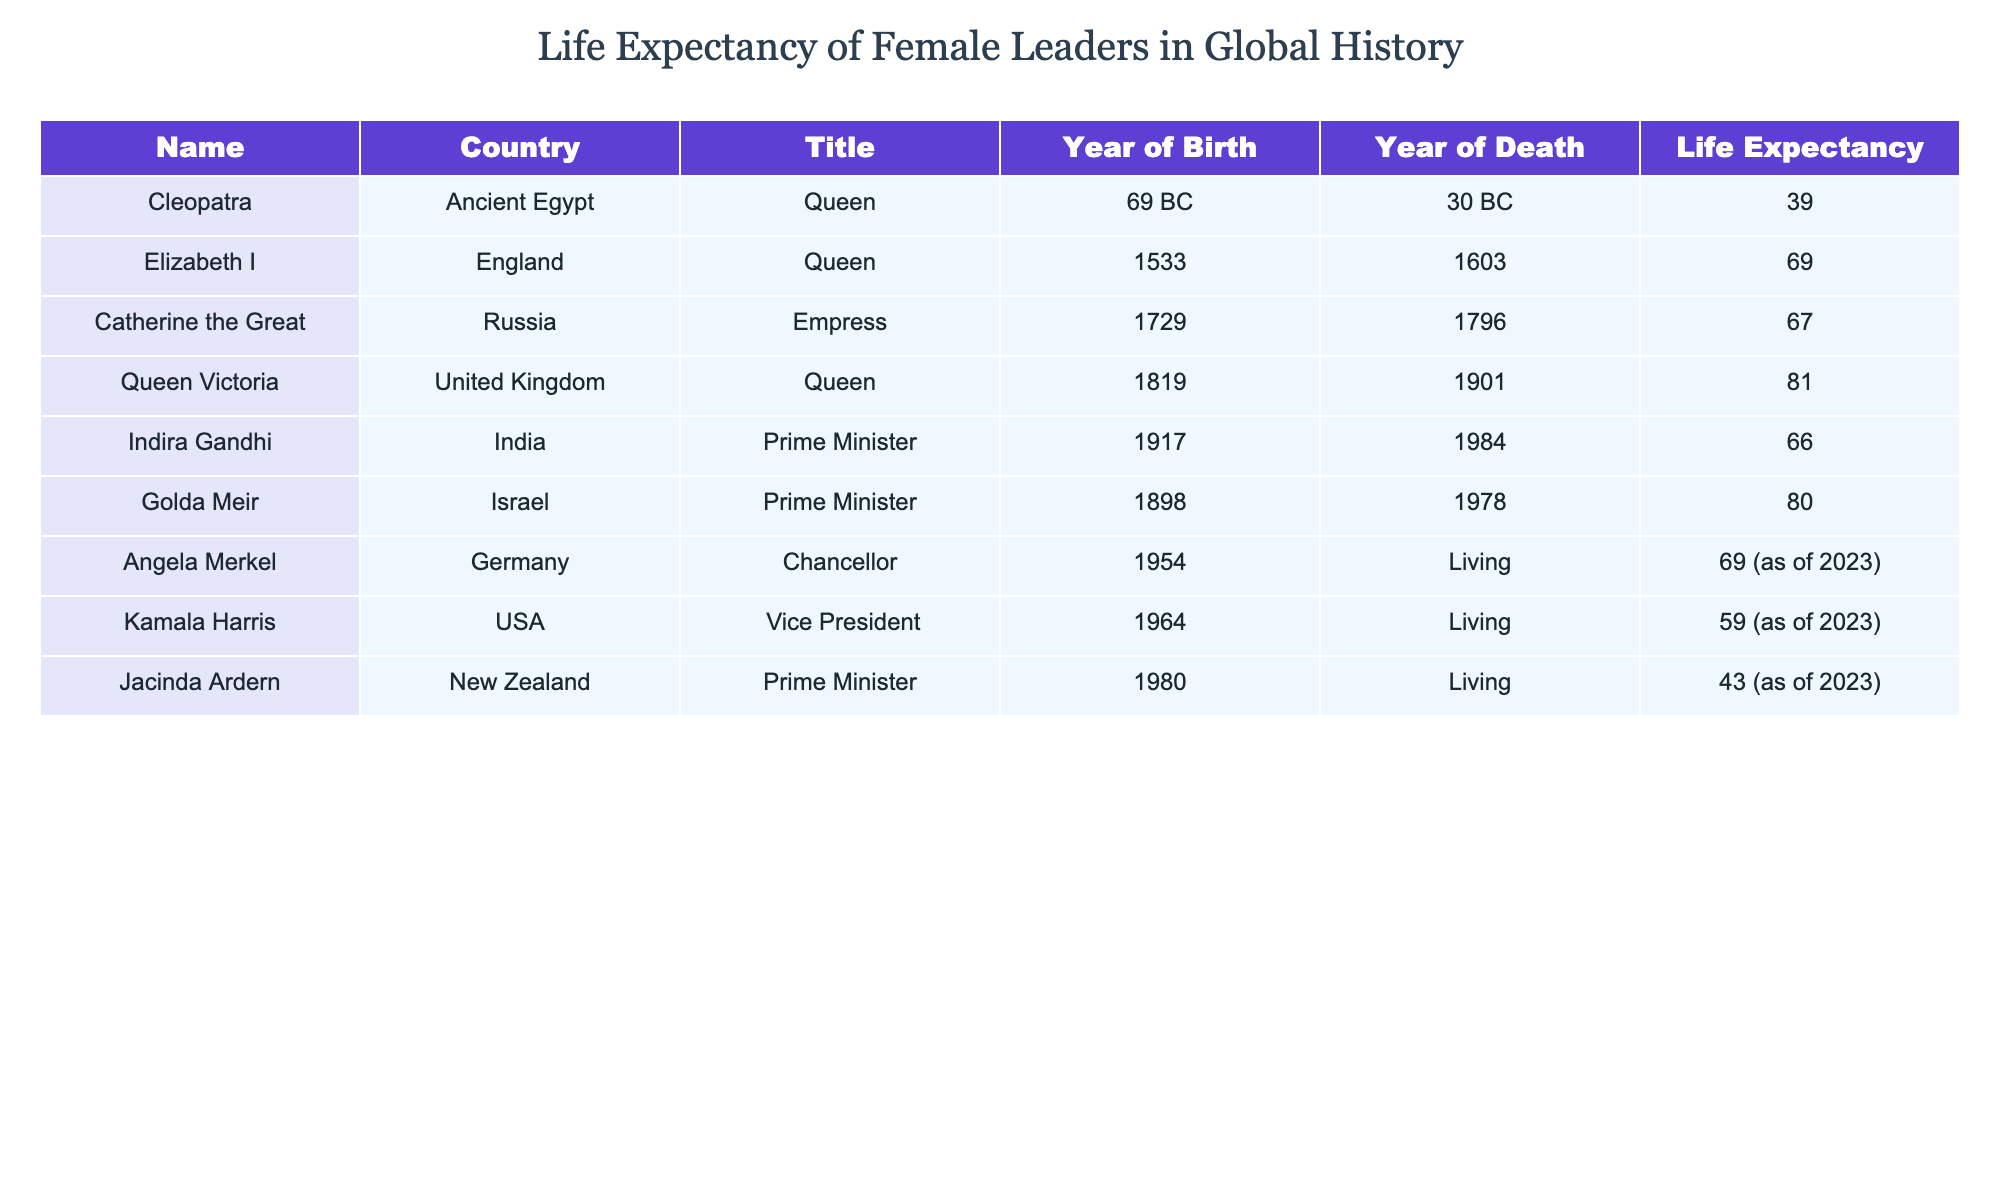What is the life expectancy of Cleopatra? Referring to the table, under the "Life Expectancy" column, Cleopatra shows a value of 39 years.
Answer: 39 Which female leader has the longest life expectancy according to the table? The table lists the life expectancies, and the highest value is 81 years for Queen Victoria.
Answer: 81 How many years did Indira Gandhi live compared to Golda Meir? Indira Gandhi lived for 66 years and Golda Meir lived for 80 years. The difference in their life expectancy is calculated as 80 - 66 = 14 years.
Answer: 14 Is it true that Angela Merkel was younger than Kamala Harris at the time of her passing? Angela Merkel was born in 1954 and is still living as of 2023, while Kamala Harris was born in 1964 and is also living, thus we cannot compare since no death year for Merkel is provided.
Answer: No What are the average life expectancies of female leaders born before 1900? The females born before 1900 are Cleopatra (39), Elizabeth I (69), Catherine the Great (67), Queen Victoria (81), Indira Gandhi (66), and Golda Meir (80). Adding these gives 39 + 69 + 67 + 81 + 66 + 80 = 402. With 6 leaders, the average is 402/6 = 67.
Answer: 67 Which female leader was born the earliest, and what was her life expectancy? Cleopatra, born in 69 BC, shows a life expectancy of 39 years in the table. This makes her the earliest born female leader.
Answer: 39 Did any female leader in the table live beyond 80 years? The only leader listed in the table with a life expectancy greater than 80 years is Queen Victoria at 81 years.
Answer: Yes How many female leaders have an unspecified year of death? Referring to the table, Angela Merkel, Kamala Harris, and Jacinda Ardern all have 'Living' as their year of death, which counts as three leaders with unspecified death years.
Answer: 3 What is the difference in life expectancy between the youngest and oldest female leaders listed? The youngest leader listed is Jacinda Ardern with a life expectancy of 43 years, and the oldest is Queen Victoria with a life expectancy of 81 years. The difference is 81 - 43 = 38 years.
Answer: 38 